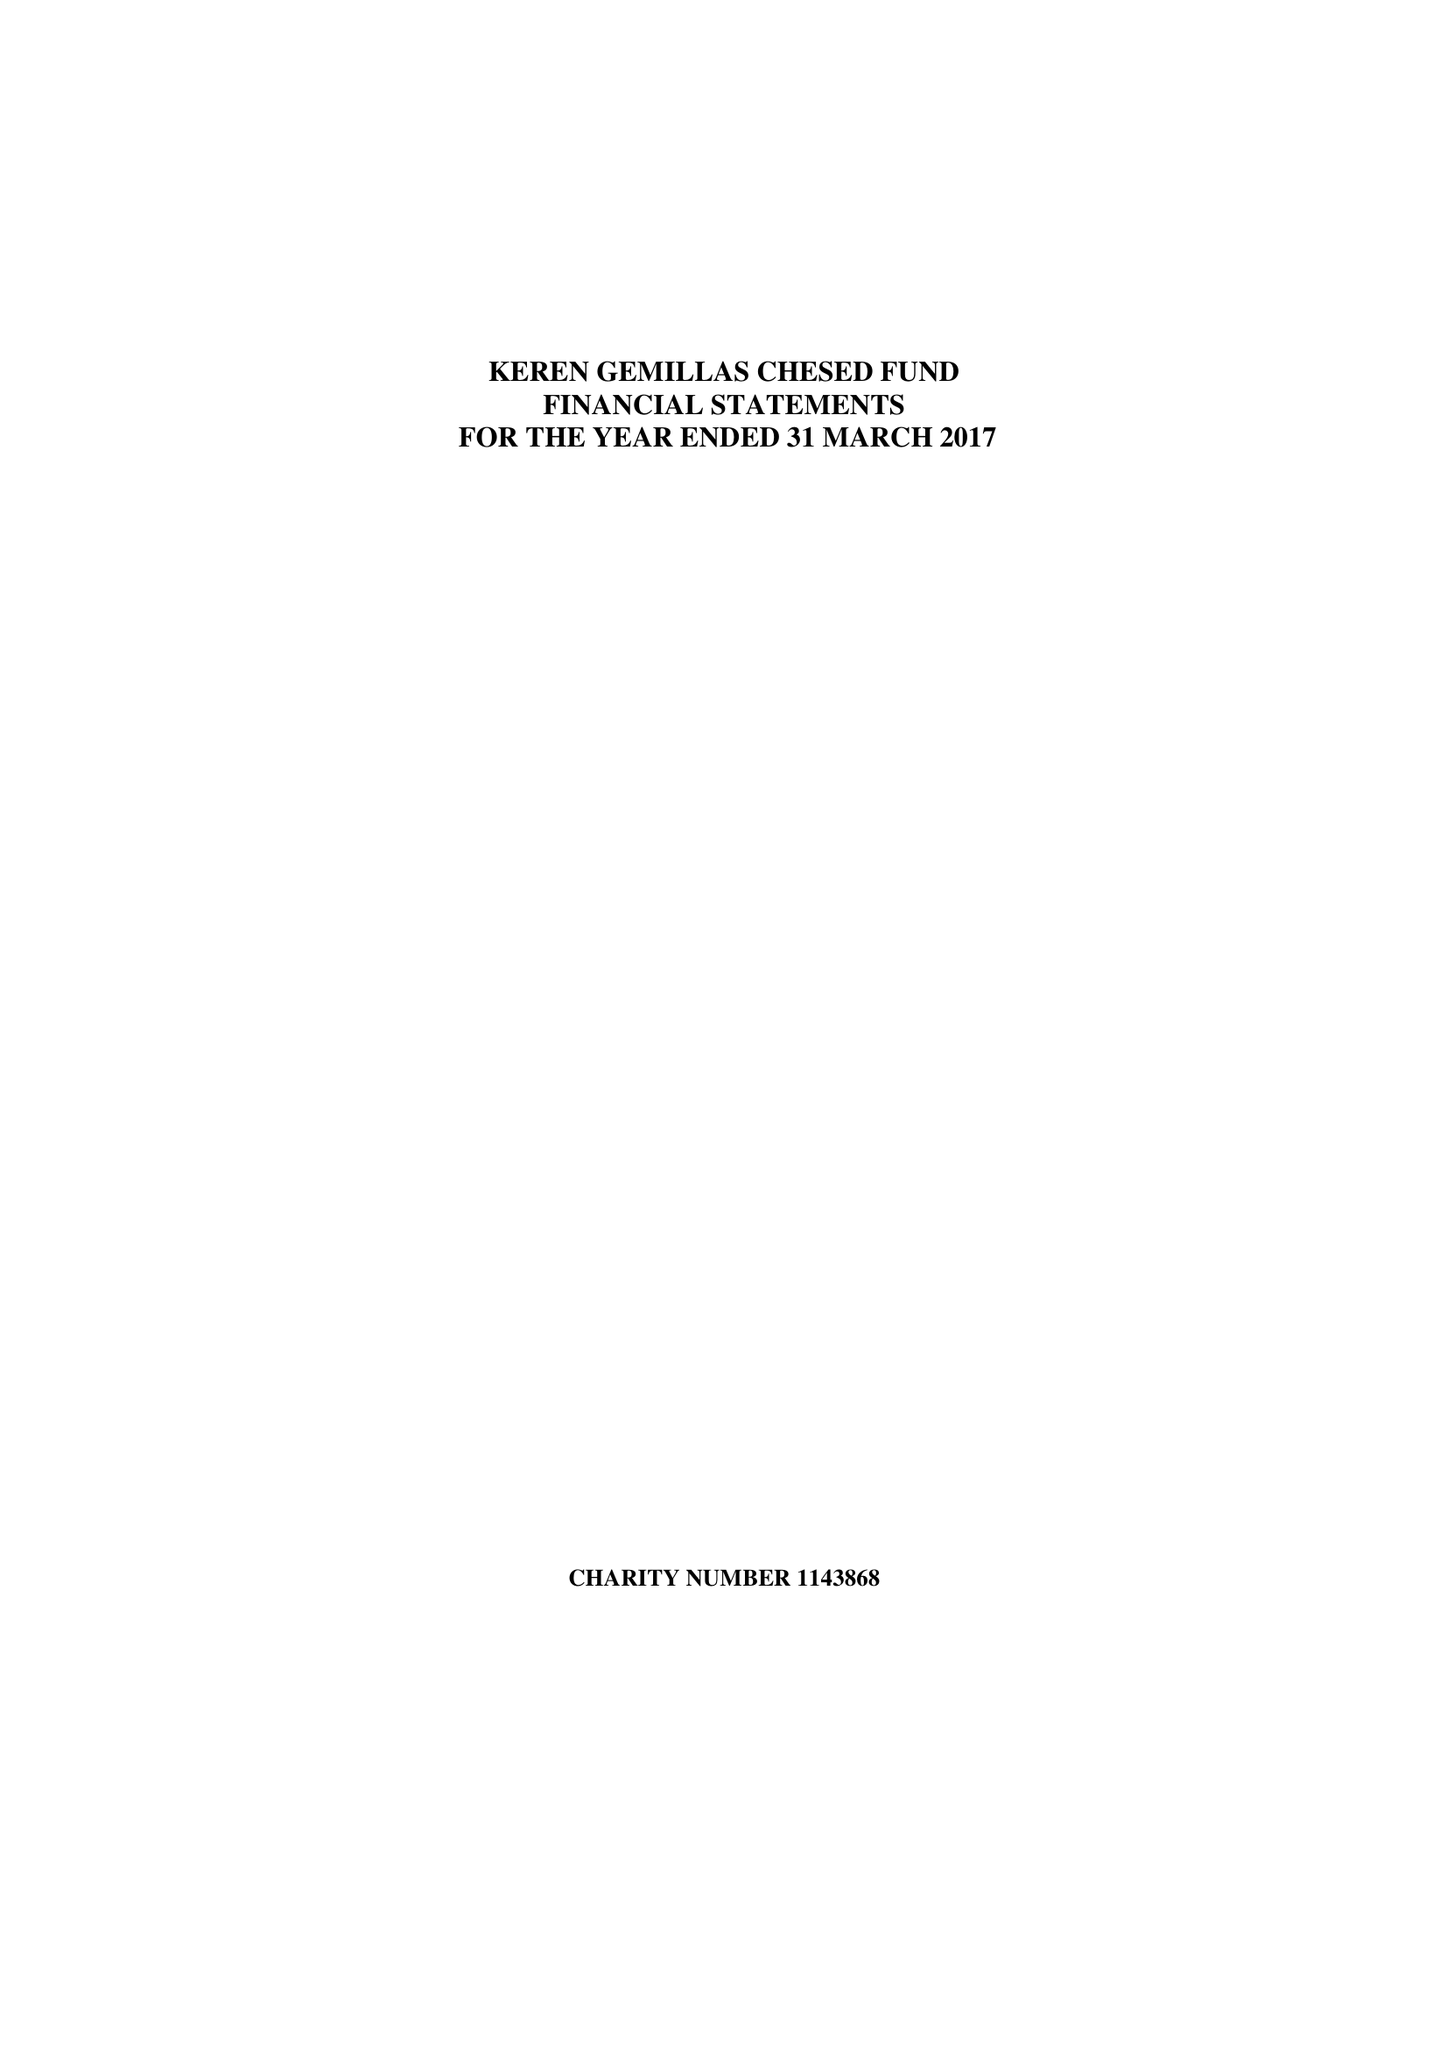What is the value for the spending_annually_in_british_pounds?
Answer the question using a single word or phrase. 121699.00 